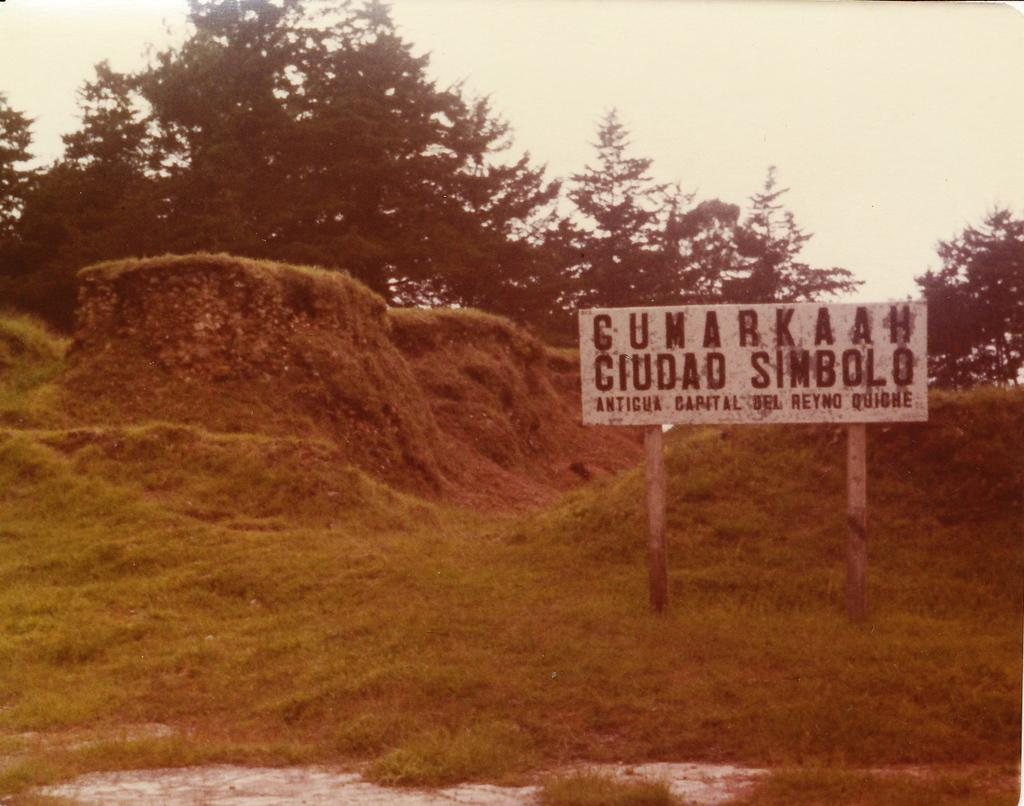What type of vegetation is present in the image? There is grass in the image. What structures can be seen in the image? There are two poles and a board in the image. What else is visible in the image besides the grass and structures? There are trees in the image. What part of the natural environment is visible in the image? The sky is visible in the image. What type of pear is sitting on the box in the image? There is no pear or box present in the image. Can you describe the shoe that is visible in the image? There is no shoe present in the image. 